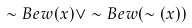Convert formula to latex. <formula><loc_0><loc_0><loc_500><loc_500>\sim B e w ( x ) \vee \sim B e w ( \sim ( x ) )</formula> 